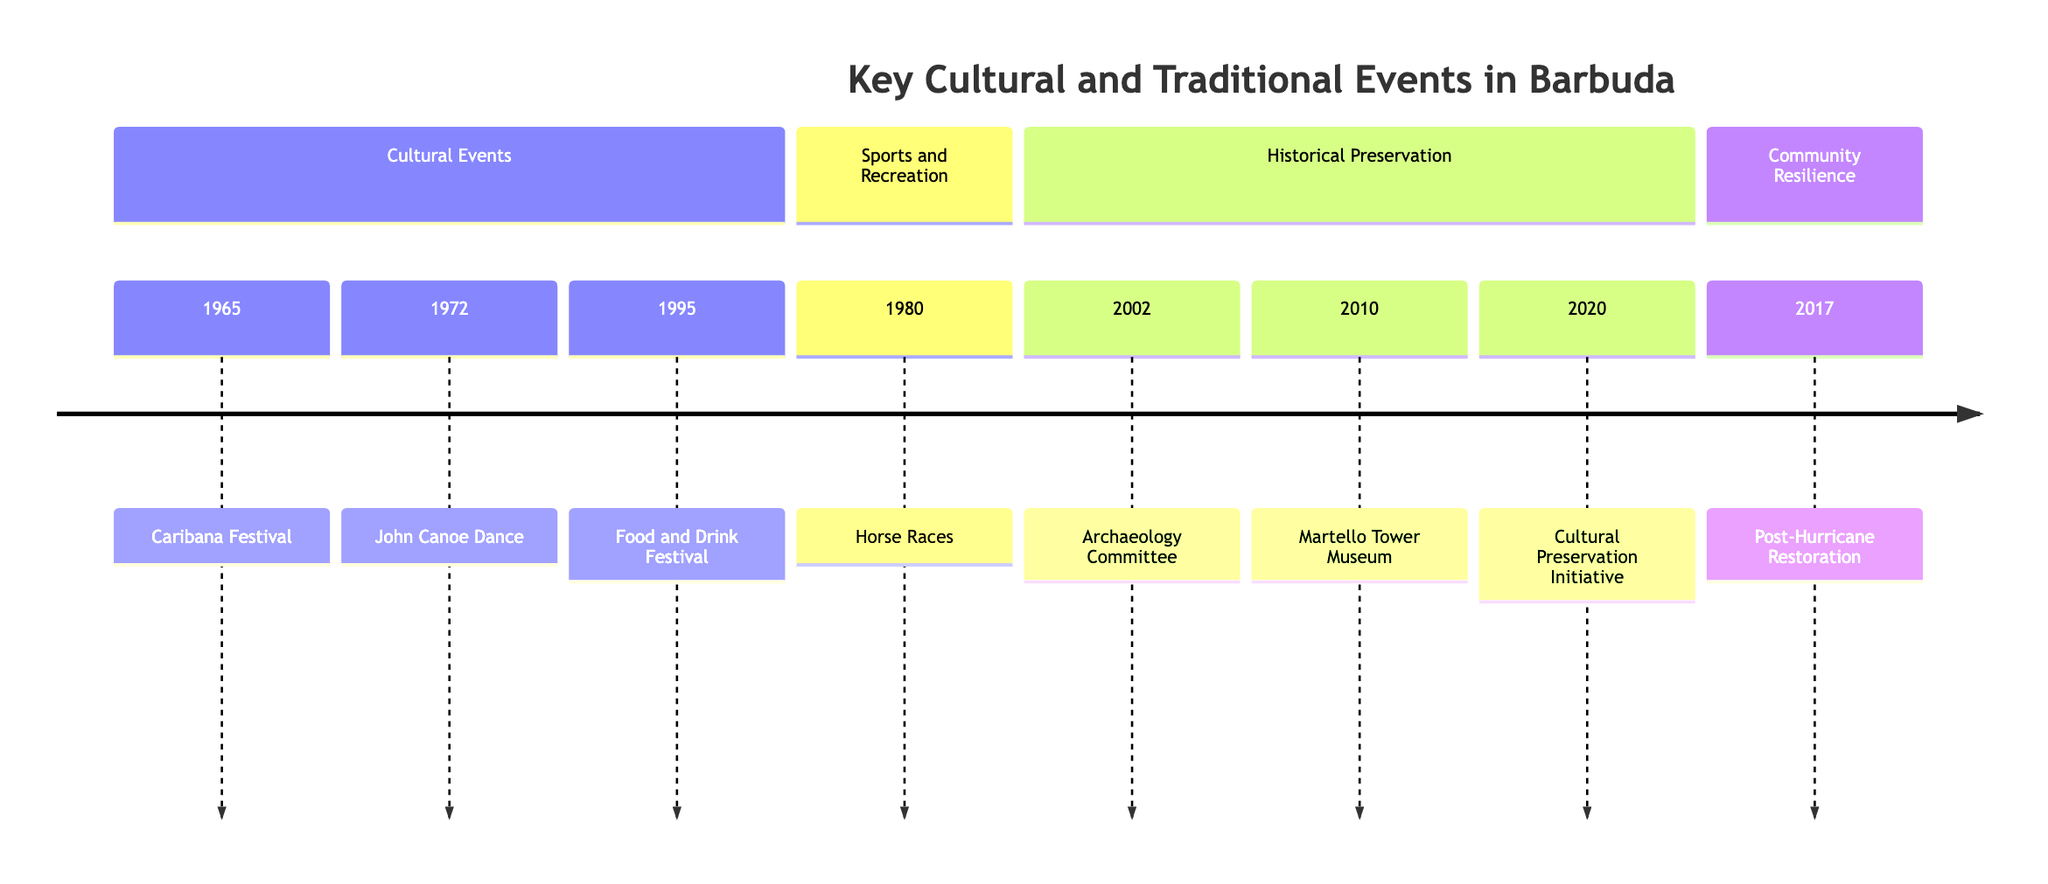What year did the Barbuda Caribana Festival start? The diagram indicates that the Barbuda Caribana Festival was established in 1965, which is directly stated in the timeline.
Answer: 1965 How many events are listed in the timeline? By counting the number of distinct events provided in the timeline, we find there are a total of 8 key cultural and traditional events documented.
Answer: 8 Which event was introduced in 1980? The timeline specifies that the inaugural Barbuda Horse Races took place in 1980, thus identifying this specific event.
Answer: Barbuda Horse Races What significant event happened in 2017? According to the diagram, the significant event in 2017 is the community-led restoration after Hurricane Irma, highlighting the resilience of the local community.
Answer: Community-led Restoration after Hurricane Irma What is the latest event mentioned in the timeline? The diagram shows the latest event to be the launch of the Barbuda Cultural Preservation Initiative in 2020, marking its occurrence as the most recent.
Answer: Launch of Barbuda Cultural Preservation Initiative What type of traditional event was revived in 1972? The timeline indicates that the John Canoe Dance, a type of traditional dance, was reintroduced in Barbuda in 1972, specifically highlighting its cultural significance.
Answer: John Canoe Dance Which event is associated with preserving Barbuda's historical sites? The formation of the Barbuda Research and Archaeology Committee in 2002 is the event related to preserving historical sites, as stated in the description on the timeline.
Answer: Formation of Barbuda Research and Archaeology Committee Which section does the Barbuda Food and Drink Festival belong to? Given that the Barbuda Food and Drink Festival started in 1995, it falls under the section labeled 'Cultural Events' that includes various celebrations of Barbuda's culture.
Answer: Cultural Events How many years elapsed between the establishment of the Barbuda Caribana Festival and the first Food and Drink Festival? The Barbuda Caribana Festival started in 1965 and the Food and Drink Festival began in 1995. Calculating the difference, we have 1995 - 1965, which shows 30 years elapsed between these two events.
Answer: 30 years 